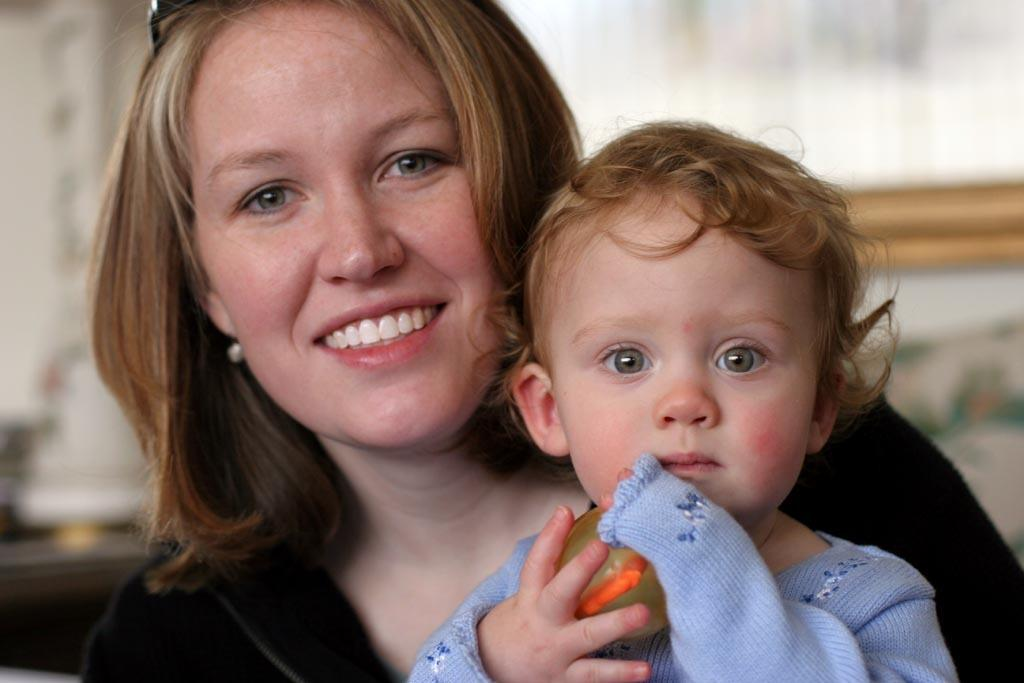Who is the main subject in the image? There is a woman in the image. What is the woman doing in the image? The woman is smiling and holding a baby. What type of pig can be seen in the image? There is no pig present in the image. What is the woman's afterthought after holding the baby in the image? The provided facts do not mention any afterthoughts or thoughts of the woman, so we cannot determine her afterthought. 